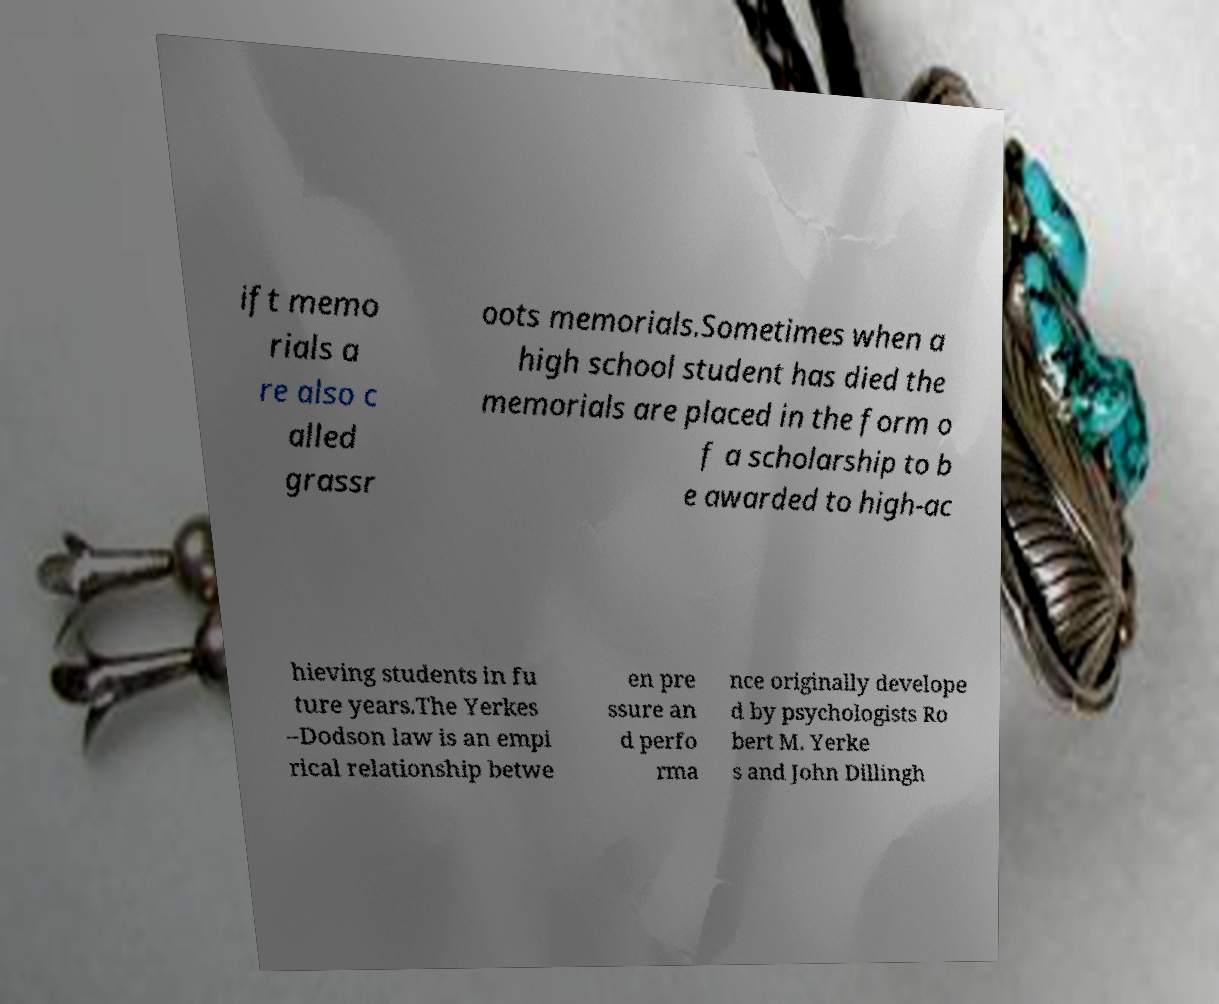Can you accurately transcribe the text from the provided image for me? ift memo rials a re also c alled grassr oots memorials.Sometimes when a high school student has died the memorials are placed in the form o f a scholarship to b e awarded to high-ac hieving students in fu ture years.The Yerkes –Dodson law is an empi rical relationship betwe en pre ssure an d perfo rma nce originally develope d by psychologists Ro bert M. Yerke s and John Dillingh 